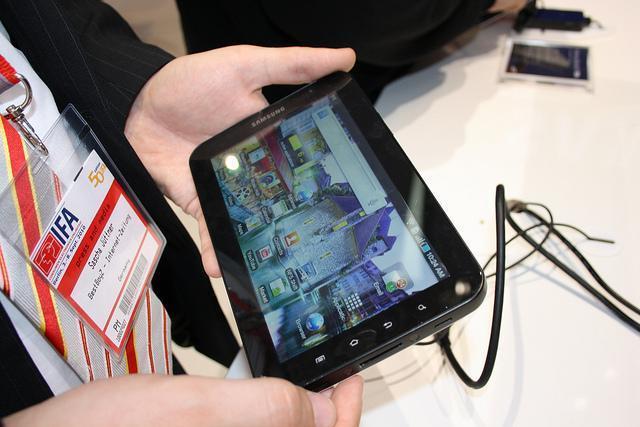How many cell phones can be seen?
Give a very brief answer. 2. How many vases in the picture?
Give a very brief answer. 0. 